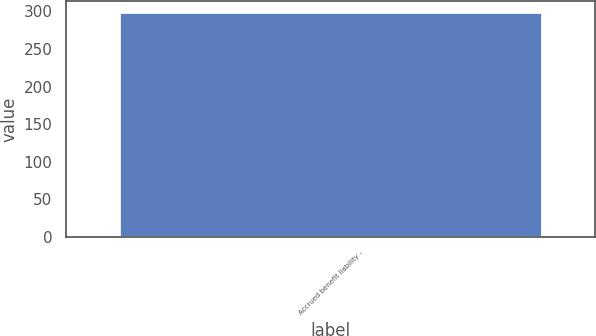<chart> <loc_0><loc_0><loc_500><loc_500><bar_chart><fcel>Accrued benefit liability -<nl><fcel>299<nl></chart> 